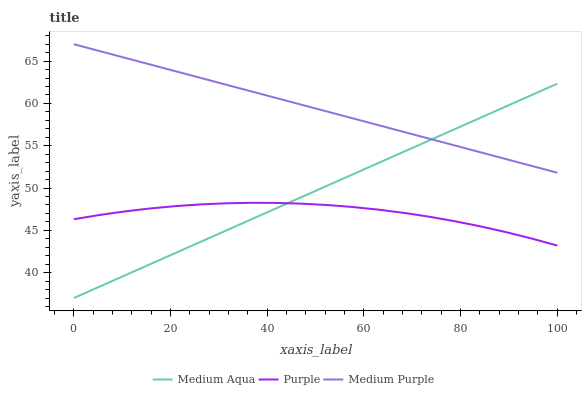Does Purple have the minimum area under the curve?
Answer yes or no. Yes. Does Medium Purple have the maximum area under the curve?
Answer yes or no. Yes. Does Medium Aqua have the minimum area under the curve?
Answer yes or no. No. Does Medium Aqua have the maximum area under the curve?
Answer yes or no. No. Is Medium Aqua the smoothest?
Answer yes or no. Yes. Is Purple the roughest?
Answer yes or no. Yes. Is Medium Purple the smoothest?
Answer yes or no. No. Is Medium Purple the roughest?
Answer yes or no. No. Does Medium Aqua have the lowest value?
Answer yes or no. Yes. Does Medium Purple have the lowest value?
Answer yes or no. No. Does Medium Purple have the highest value?
Answer yes or no. Yes. Does Medium Aqua have the highest value?
Answer yes or no. No. Is Purple less than Medium Purple?
Answer yes or no. Yes. Is Medium Purple greater than Purple?
Answer yes or no. Yes. Does Medium Purple intersect Medium Aqua?
Answer yes or no. Yes. Is Medium Purple less than Medium Aqua?
Answer yes or no. No. Is Medium Purple greater than Medium Aqua?
Answer yes or no. No. Does Purple intersect Medium Purple?
Answer yes or no. No. 